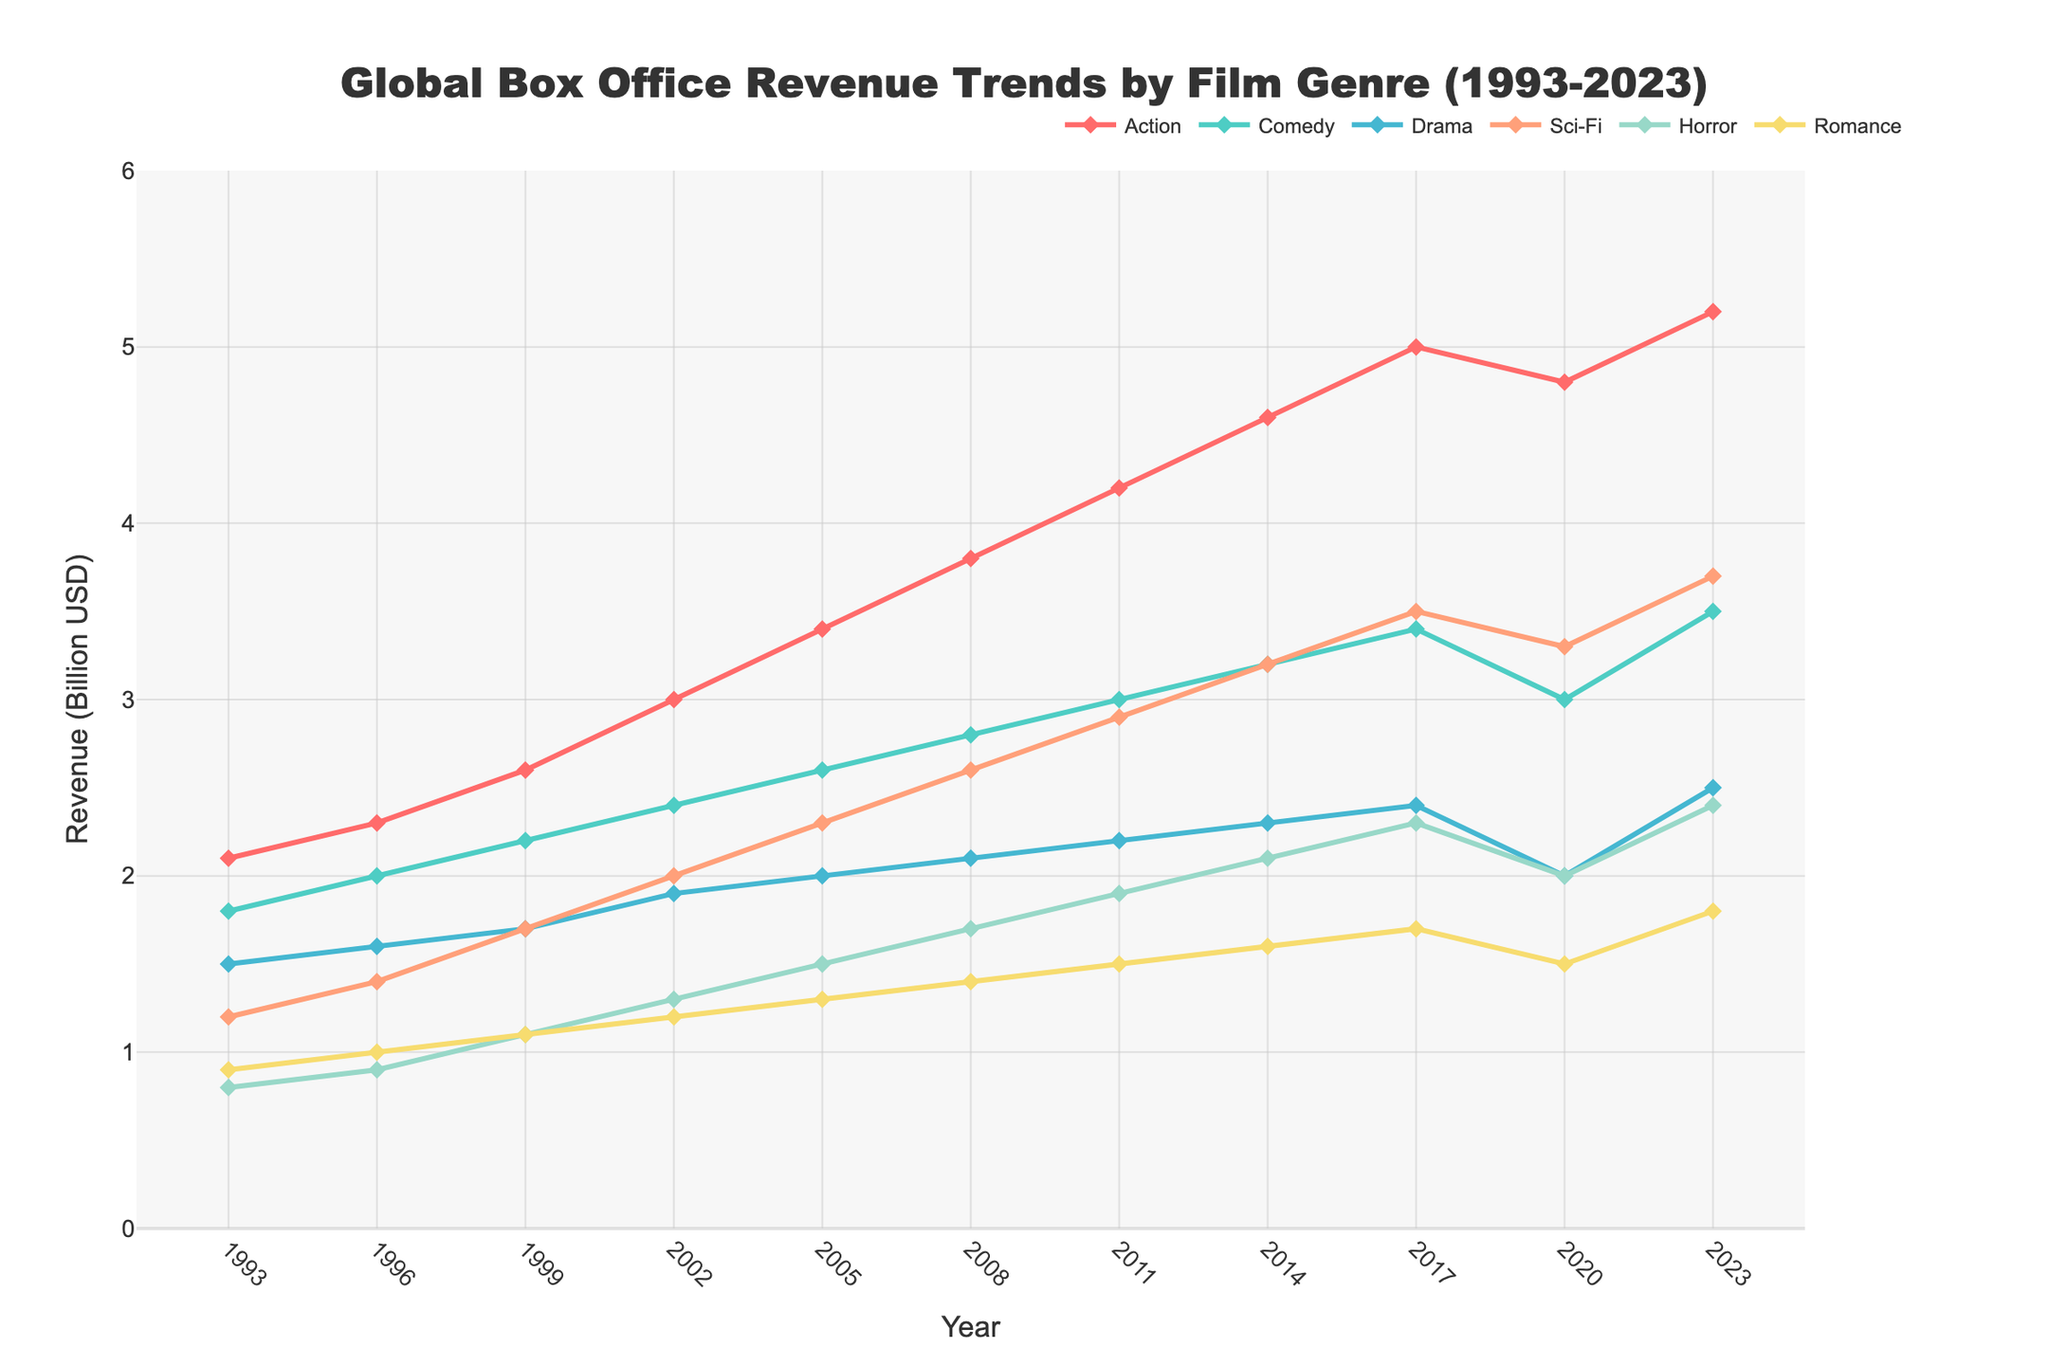What is the overall trend of Action genre revenue from 1993 to 2023? The Action genre revenue shows a continuous increase from 2.1 billion USD in 1993 to 5.2 billion USD in 2023. This indicates a positive growth trend over the 30-year period.
Answer: Increasing Which genre had the highest revenue in 2023? In 2023, the Action genre had the highest revenue, reaching 5.2 billion USD according to the plotted data lines.
Answer: Action How did Comedy genre revenue change from 2002 to 2020? Comedy genre revenue increased from 2.4 billion USD in 2002 to 3.0 billion USD in 2011 and remained stable around this value, finally dropping slightly to 3.0 billion USD in 2020.
Answer: Increased then stabilized Compare the revenues of Sci-Fi and Drama genres in 2017. Which one was higher and by how much? In 2017, the revenue for Sci-Fi was 3.5 billion USD while Drama was 2.4 billion USD. The Sci-Fi genre's revenue was higher by 1.1 billion USD.
Answer: Sci-Fi, 1.1 billion USD What is the difference between the highest and lowest genre revenues in 2023? The highest revenue in 2023 was for the Action genre at 5.2 billion USD, and the lowest was for Romance at 1.8 billion USD. The difference between them is 5.2 - 1.8 = 3.4 billion USD.
Answer: 3.4 billion USD Which genre exhibited the most consistent revenue increase over the years? The Action genre exhibited the most consistent increase in revenue, growing steadily from 2.1 billion USD in 1993 to 5.2 billion USD in 2023 with no significant drops.
Answer: Action By what percentage did the Sci-Fi genre revenue increase from 2005 to 2023? In 2005, Sci-Fi revenue was 2.3 billion USD. In 2023, it reached 3.7 billion USD. The increase is (3.7 - 2.3) / 2.3 * 100% = 60.87%.
Answer: 60.87% Which genres showed a decrease in revenue between 2017 and 2020? The Action genre showed a slight decrease, dropping from 5.0 billion USD in 2017 to 4.8 billion USD in 2020. Similarly, the Comedy genre decreased from 3.4 billion USD in 2017 to 3.0 billion USD in 2020.
Answer: Action, Comedy What were the relative positions of Horror and Romance genres in 1993 compared to 2023? In 1993, Horror revenue was 0.8 billion USD and Romance was 0.9 billion USD, with Romance slightly higher. In 2023, Horror revenue was 2.4 billion USD, whereas Romance was 1.8 billion USD, making Horror higher than Romance.
Answer: Horror surpassed Romance by 2023 